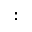<formula> <loc_0><loc_0><loc_500><loc_500>\colon</formula> 